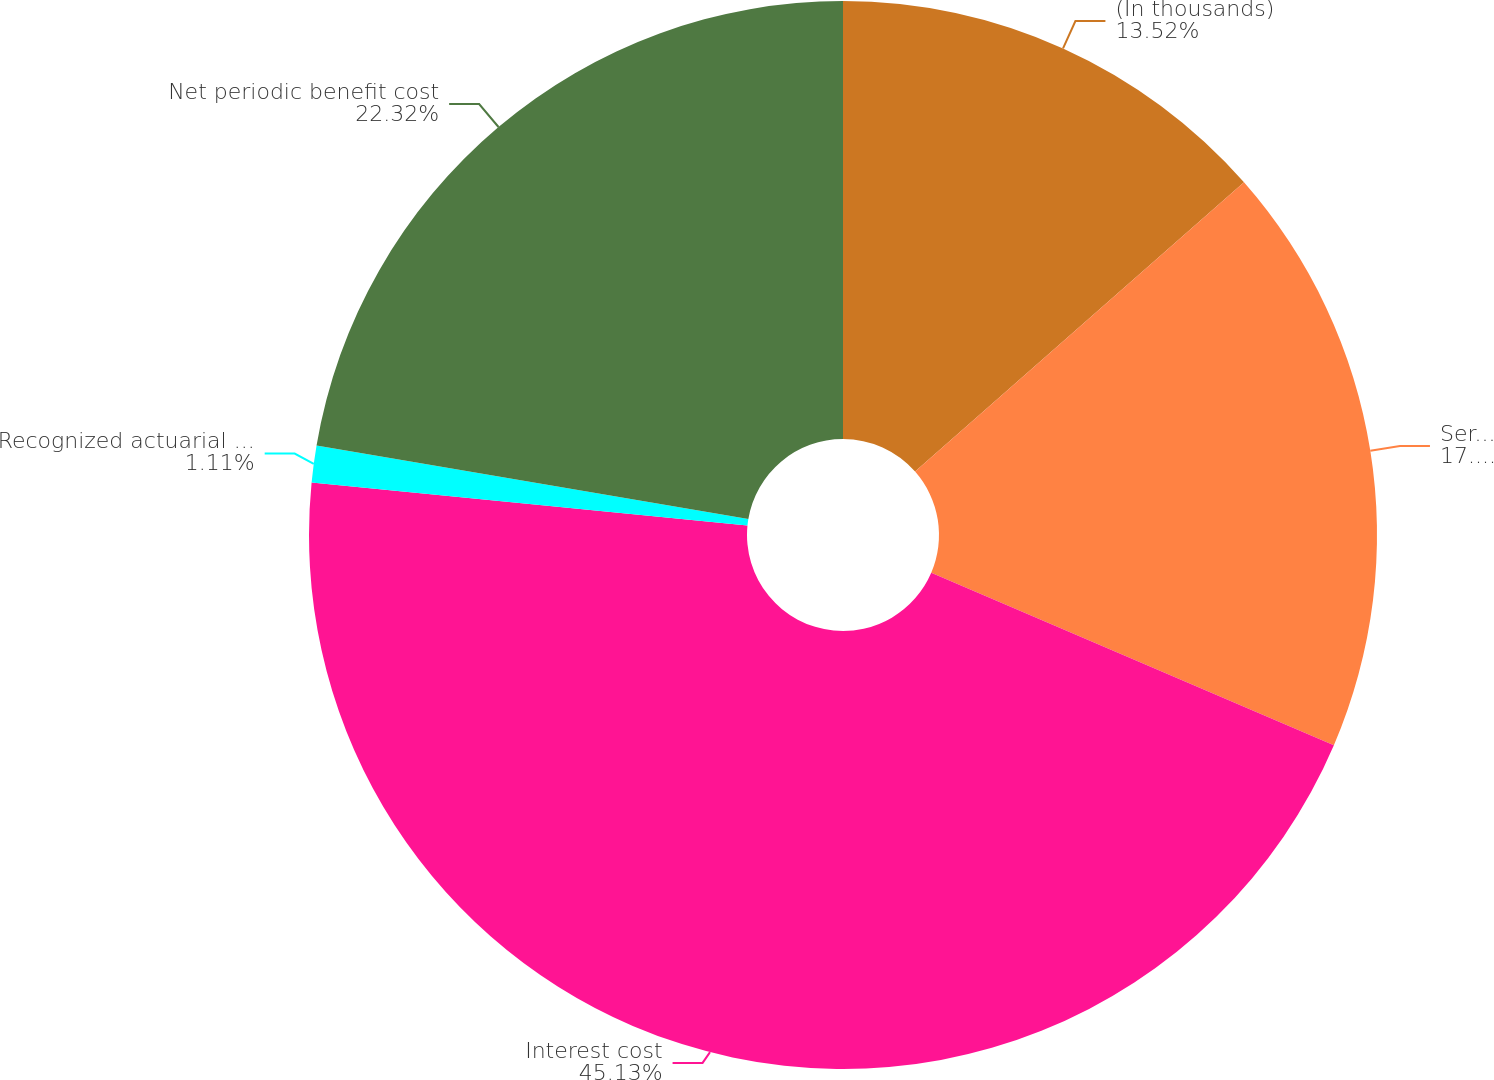Convert chart. <chart><loc_0><loc_0><loc_500><loc_500><pie_chart><fcel>(In thousands)<fcel>Service cost<fcel>Interest cost<fcel>Recognized actuarial (gain) or<fcel>Net periodic benefit cost<nl><fcel>13.52%<fcel>17.92%<fcel>45.13%<fcel>1.11%<fcel>22.32%<nl></chart> 